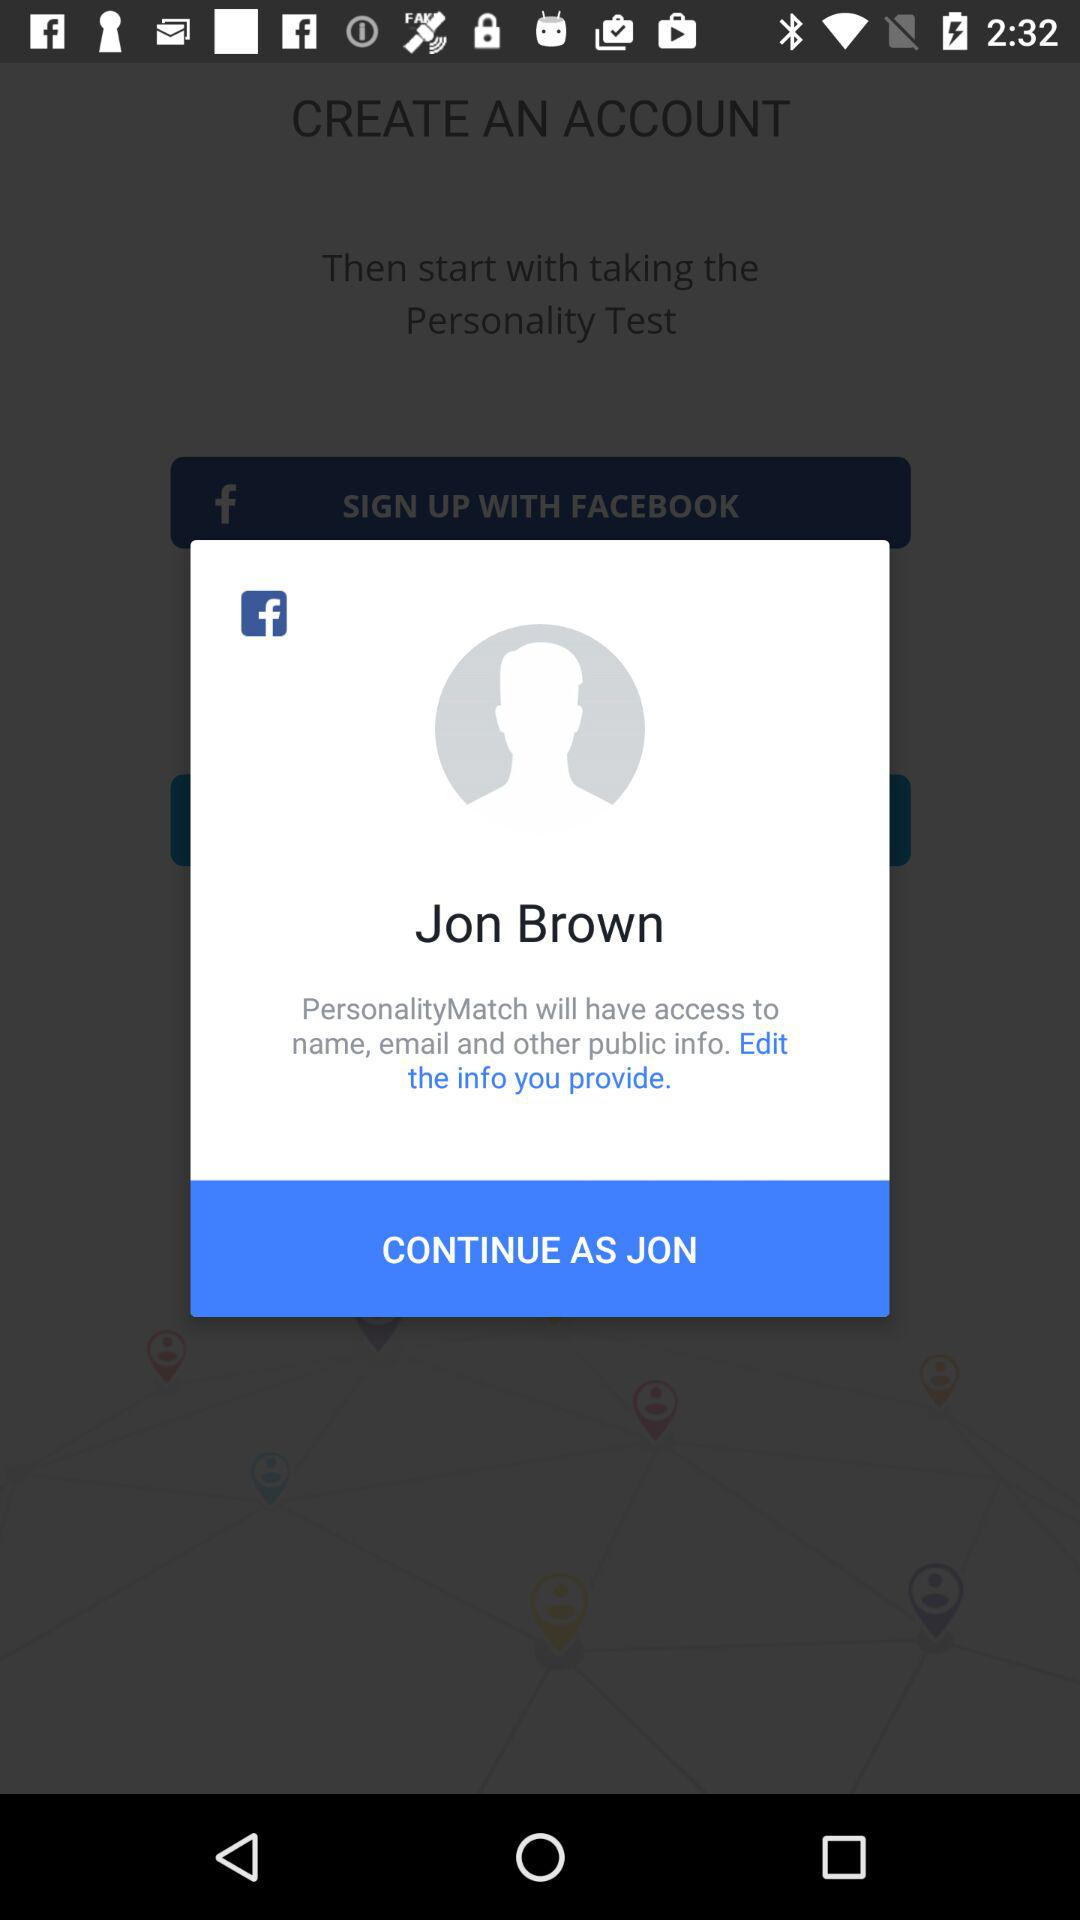What is the name of the user? The name of the user is Jon Brown. 